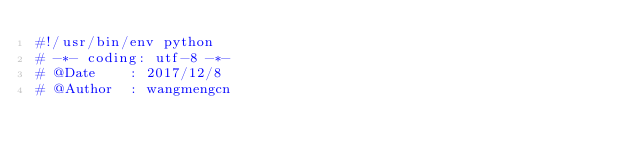Convert code to text. <code><loc_0><loc_0><loc_500><loc_500><_Python_>#!/usr/bin/env python
# -*- coding: utf-8 -*-
# @Date    : 2017/12/8
# @Author  : wangmengcn</code> 